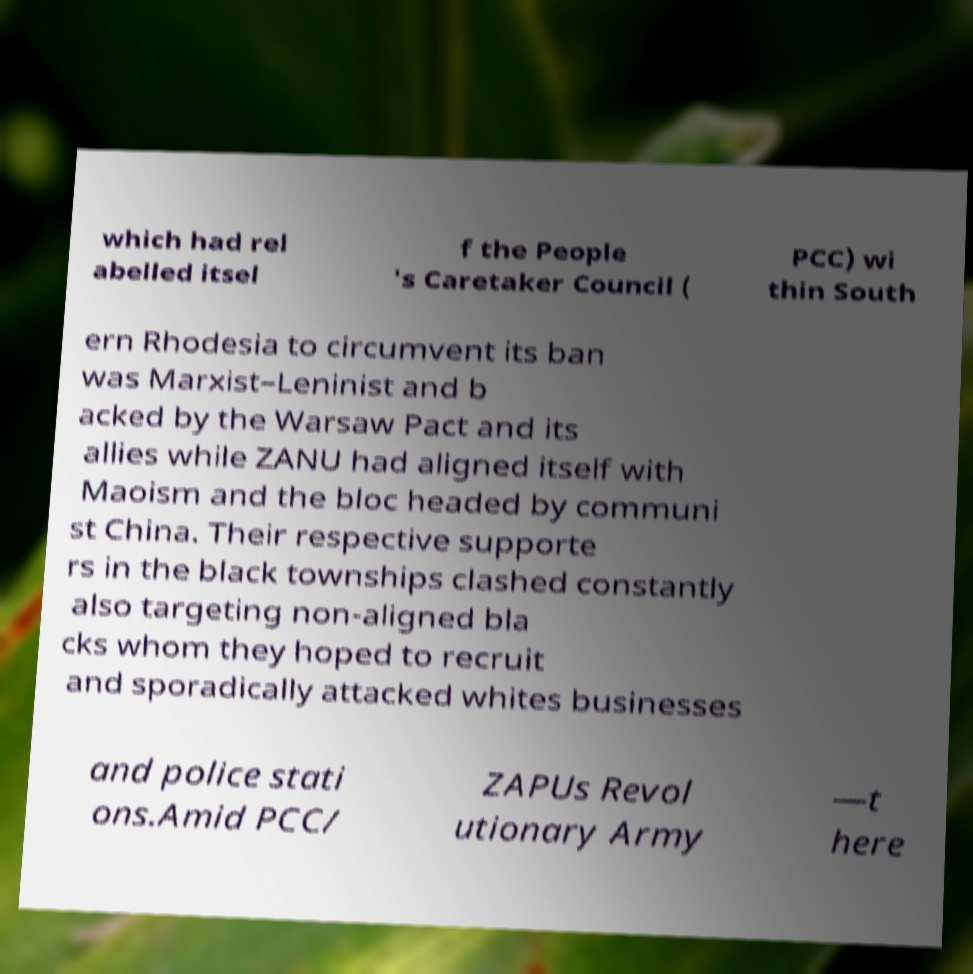I need the written content from this picture converted into text. Can you do that? which had rel abelled itsel f the People 's Caretaker Council ( PCC) wi thin South ern Rhodesia to circumvent its ban was Marxist–Leninist and b acked by the Warsaw Pact and its allies while ZANU had aligned itself with Maoism and the bloc headed by communi st China. Their respective supporte rs in the black townships clashed constantly also targeting non-aligned bla cks whom they hoped to recruit and sporadically attacked whites businesses and police stati ons.Amid PCC/ ZAPUs Revol utionary Army —t here 